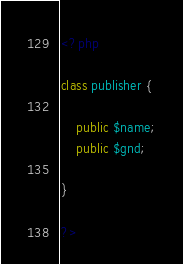<code> <loc_0><loc_0><loc_500><loc_500><_PHP_><?php

class publisher {
	
	public $name;
	public $gnd;

}

?></code> 